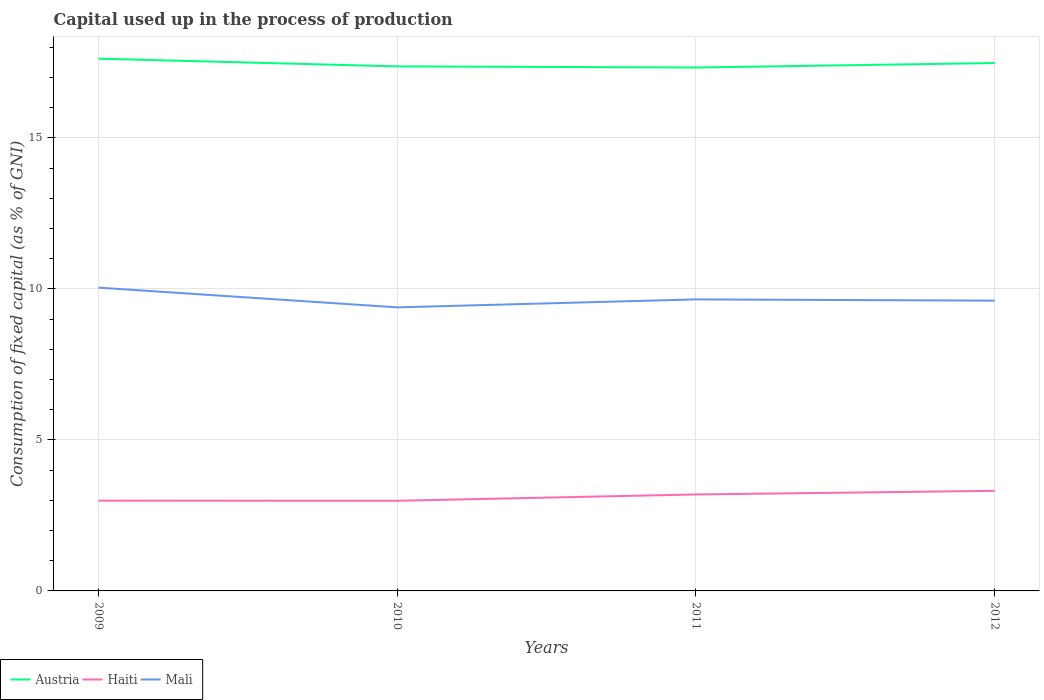Does the line corresponding to Austria intersect with the line corresponding to Mali?
Keep it short and to the point. No. Across all years, what is the maximum capital used up in the process of production in Austria?
Ensure brevity in your answer.  17.33. In which year was the capital used up in the process of production in Haiti maximum?
Keep it short and to the point. 2010. What is the total capital used up in the process of production in Haiti in the graph?
Provide a succinct answer. -0.2. What is the difference between the highest and the second highest capital used up in the process of production in Haiti?
Keep it short and to the point. 0.33. What is the difference between the highest and the lowest capital used up in the process of production in Haiti?
Provide a succinct answer. 2. How many lines are there?
Provide a short and direct response. 3. What is the difference between two consecutive major ticks on the Y-axis?
Your answer should be compact. 5. Does the graph contain any zero values?
Your answer should be compact. No. Where does the legend appear in the graph?
Offer a terse response. Bottom left. How are the legend labels stacked?
Provide a succinct answer. Horizontal. What is the title of the graph?
Your answer should be compact. Capital used up in the process of production. Does "Guam" appear as one of the legend labels in the graph?
Your response must be concise. No. What is the label or title of the Y-axis?
Give a very brief answer. Consumption of fixed capital (as % of GNI). What is the Consumption of fixed capital (as % of GNI) of Austria in 2009?
Provide a succinct answer. 17.62. What is the Consumption of fixed capital (as % of GNI) in Haiti in 2009?
Your response must be concise. 2.99. What is the Consumption of fixed capital (as % of GNI) of Mali in 2009?
Provide a short and direct response. 10.04. What is the Consumption of fixed capital (as % of GNI) of Austria in 2010?
Offer a very short reply. 17.37. What is the Consumption of fixed capital (as % of GNI) in Haiti in 2010?
Offer a very short reply. 2.98. What is the Consumption of fixed capital (as % of GNI) in Mali in 2010?
Offer a very short reply. 9.39. What is the Consumption of fixed capital (as % of GNI) of Austria in 2011?
Your response must be concise. 17.33. What is the Consumption of fixed capital (as % of GNI) of Haiti in 2011?
Your response must be concise. 3.19. What is the Consumption of fixed capital (as % of GNI) in Mali in 2011?
Your answer should be compact. 9.65. What is the Consumption of fixed capital (as % of GNI) of Austria in 2012?
Provide a short and direct response. 17.48. What is the Consumption of fixed capital (as % of GNI) of Haiti in 2012?
Offer a very short reply. 3.31. What is the Consumption of fixed capital (as % of GNI) in Mali in 2012?
Provide a short and direct response. 9.61. Across all years, what is the maximum Consumption of fixed capital (as % of GNI) in Austria?
Keep it short and to the point. 17.62. Across all years, what is the maximum Consumption of fixed capital (as % of GNI) in Haiti?
Your answer should be compact. 3.31. Across all years, what is the maximum Consumption of fixed capital (as % of GNI) of Mali?
Your answer should be very brief. 10.04. Across all years, what is the minimum Consumption of fixed capital (as % of GNI) in Austria?
Ensure brevity in your answer.  17.33. Across all years, what is the minimum Consumption of fixed capital (as % of GNI) in Haiti?
Your response must be concise. 2.98. Across all years, what is the minimum Consumption of fixed capital (as % of GNI) in Mali?
Offer a very short reply. 9.39. What is the total Consumption of fixed capital (as % of GNI) in Austria in the graph?
Offer a very short reply. 69.79. What is the total Consumption of fixed capital (as % of GNI) in Haiti in the graph?
Provide a succinct answer. 12.48. What is the total Consumption of fixed capital (as % of GNI) of Mali in the graph?
Provide a succinct answer. 38.69. What is the difference between the Consumption of fixed capital (as % of GNI) in Austria in 2009 and that in 2010?
Provide a succinct answer. 0.25. What is the difference between the Consumption of fixed capital (as % of GNI) in Haiti in 2009 and that in 2010?
Your answer should be compact. 0. What is the difference between the Consumption of fixed capital (as % of GNI) in Mali in 2009 and that in 2010?
Your response must be concise. 0.65. What is the difference between the Consumption of fixed capital (as % of GNI) in Austria in 2009 and that in 2011?
Provide a succinct answer. 0.29. What is the difference between the Consumption of fixed capital (as % of GNI) of Haiti in 2009 and that in 2011?
Provide a short and direct response. -0.2. What is the difference between the Consumption of fixed capital (as % of GNI) of Mali in 2009 and that in 2011?
Your response must be concise. 0.39. What is the difference between the Consumption of fixed capital (as % of GNI) in Austria in 2009 and that in 2012?
Your response must be concise. 0.14. What is the difference between the Consumption of fixed capital (as % of GNI) of Haiti in 2009 and that in 2012?
Provide a short and direct response. -0.32. What is the difference between the Consumption of fixed capital (as % of GNI) in Mali in 2009 and that in 2012?
Offer a very short reply. 0.43. What is the difference between the Consumption of fixed capital (as % of GNI) of Austria in 2010 and that in 2011?
Offer a terse response. 0.04. What is the difference between the Consumption of fixed capital (as % of GNI) of Haiti in 2010 and that in 2011?
Your answer should be compact. -0.21. What is the difference between the Consumption of fixed capital (as % of GNI) of Mali in 2010 and that in 2011?
Ensure brevity in your answer.  -0.26. What is the difference between the Consumption of fixed capital (as % of GNI) in Austria in 2010 and that in 2012?
Your response must be concise. -0.11. What is the difference between the Consumption of fixed capital (as % of GNI) in Haiti in 2010 and that in 2012?
Make the answer very short. -0.33. What is the difference between the Consumption of fixed capital (as % of GNI) of Mali in 2010 and that in 2012?
Offer a terse response. -0.22. What is the difference between the Consumption of fixed capital (as % of GNI) in Austria in 2011 and that in 2012?
Your answer should be very brief. -0.15. What is the difference between the Consumption of fixed capital (as % of GNI) in Haiti in 2011 and that in 2012?
Give a very brief answer. -0.12. What is the difference between the Consumption of fixed capital (as % of GNI) in Mali in 2011 and that in 2012?
Your response must be concise. 0.04. What is the difference between the Consumption of fixed capital (as % of GNI) of Austria in 2009 and the Consumption of fixed capital (as % of GNI) of Haiti in 2010?
Provide a succinct answer. 14.64. What is the difference between the Consumption of fixed capital (as % of GNI) of Austria in 2009 and the Consumption of fixed capital (as % of GNI) of Mali in 2010?
Keep it short and to the point. 8.23. What is the difference between the Consumption of fixed capital (as % of GNI) in Haiti in 2009 and the Consumption of fixed capital (as % of GNI) in Mali in 2010?
Your answer should be very brief. -6.4. What is the difference between the Consumption of fixed capital (as % of GNI) in Austria in 2009 and the Consumption of fixed capital (as % of GNI) in Haiti in 2011?
Your answer should be compact. 14.43. What is the difference between the Consumption of fixed capital (as % of GNI) in Austria in 2009 and the Consumption of fixed capital (as % of GNI) in Mali in 2011?
Provide a succinct answer. 7.97. What is the difference between the Consumption of fixed capital (as % of GNI) in Haiti in 2009 and the Consumption of fixed capital (as % of GNI) in Mali in 2011?
Your answer should be very brief. -6.66. What is the difference between the Consumption of fixed capital (as % of GNI) of Austria in 2009 and the Consumption of fixed capital (as % of GNI) of Haiti in 2012?
Provide a succinct answer. 14.31. What is the difference between the Consumption of fixed capital (as % of GNI) of Austria in 2009 and the Consumption of fixed capital (as % of GNI) of Mali in 2012?
Give a very brief answer. 8.01. What is the difference between the Consumption of fixed capital (as % of GNI) of Haiti in 2009 and the Consumption of fixed capital (as % of GNI) of Mali in 2012?
Offer a very short reply. -6.62. What is the difference between the Consumption of fixed capital (as % of GNI) of Austria in 2010 and the Consumption of fixed capital (as % of GNI) of Haiti in 2011?
Your answer should be compact. 14.17. What is the difference between the Consumption of fixed capital (as % of GNI) of Austria in 2010 and the Consumption of fixed capital (as % of GNI) of Mali in 2011?
Ensure brevity in your answer.  7.72. What is the difference between the Consumption of fixed capital (as % of GNI) of Haiti in 2010 and the Consumption of fixed capital (as % of GNI) of Mali in 2011?
Give a very brief answer. -6.67. What is the difference between the Consumption of fixed capital (as % of GNI) of Austria in 2010 and the Consumption of fixed capital (as % of GNI) of Haiti in 2012?
Provide a short and direct response. 14.05. What is the difference between the Consumption of fixed capital (as % of GNI) of Austria in 2010 and the Consumption of fixed capital (as % of GNI) of Mali in 2012?
Your answer should be compact. 7.76. What is the difference between the Consumption of fixed capital (as % of GNI) of Haiti in 2010 and the Consumption of fixed capital (as % of GNI) of Mali in 2012?
Make the answer very short. -6.63. What is the difference between the Consumption of fixed capital (as % of GNI) in Austria in 2011 and the Consumption of fixed capital (as % of GNI) in Haiti in 2012?
Your answer should be compact. 14.01. What is the difference between the Consumption of fixed capital (as % of GNI) of Austria in 2011 and the Consumption of fixed capital (as % of GNI) of Mali in 2012?
Your response must be concise. 7.72. What is the difference between the Consumption of fixed capital (as % of GNI) in Haiti in 2011 and the Consumption of fixed capital (as % of GNI) in Mali in 2012?
Make the answer very short. -6.42. What is the average Consumption of fixed capital (as % of GNI) of Austria per year?
Give a very brief answer. 17.45. What is the average Consumption of fixed capital (as % of GNI) of Haiti per year?
Make the answer very short. 3.12. What is the average Consumption of fixed capital (as % of GNI) in Mali per year?
Provide a short and direct response. 9.67. In the year 2009, what is the difference between the Consumption of fixed capital (as % of GNI) of Austria and Consumption of fixed capital (as % of GNI) of Haiti?
Offer a very short reply. 14.63. In the year 2009, what is the difference between the Consumption of fixed capital (as % of GNI) in Austria and Consumption of fixed capital (as % of GNI) in Mali?
Offer a terse response. 7.58. In the year 2009, what is the difference between the Consumption of fixed capital (as % of GNI) in Haiti and Consumption of fixed capital (as % of GNI) in Mali?
Give a very brief answer. -7.05. In the year 2010, what is the difference between the Consumption of fixed capital (as % of GNI) of Austria and Consumption of fixed capital (as % of GNI) of Haiti?
Give a very brief answer. 14.38. In the year 2010, what is the difference between the Consumption of fixed capital (as % of GNI) of Austria and Consumption of fixed capital (as % of GNI) of Mali?
Offer a terse response. 7.98. In the year 2010, what is the difference between the Consumption of fixed capital (as % of GNI) of Haiti and Consumption of fixed capital (as % of GNI) of Mali?
Your answer should be compact. -6.4. In the year 2011, what is the difference between the Consumption of fixed capital (as % of GNI) of Austria and Consumption of fixed capital (as % of GNI) of Haiti?
Provide a short and direct response. 14.13. In the year 2011, what is the difference between the Consumption of fixed capital (as % of GNI) in Austria and Consumption of fixed capital (as % of GNI) in Mali?
Provide a succinct answer. 7.68. In the year 2011, what is the difference between the Consumption of fixed capital (as % of GNI) of Haiti and Consumption of fixed capital (as % of GNI) of Mali?
Your answer should be very brief. -6.46. In the year 2012, what is the difference between the Consumption of fixed capital (as % of GNI) in Austria and Consumption of fixed capital (as % of GNI) in Haiti?
Your answer should be compact. 14.16. In the year 2012, what is the difference between the Consumption of fixed capital (as % of GNI) in Austria and Consumption of fixed capital (as % of GNI) in Mali?
Your response must be concise. 7.87. In the year 2012, what is the difference between the Consumption of fixed capital (as % of GNI) of Haiti and Consumption of fixed capital (as % of GNI) of Mali?
Offer a terse response. -6.3. What is the ratio of the Consumption of fixed capital (as % of GNI) of Austria in 2009 to that in 2010?
Make the answer very short. 1.01. What is the ratio of the Consumption of fixed capital (as % of GNI) in Mali in 2009 to that in 2010?
Make the answer very short. 1.07. What is the ratio of the Consumption of fixed capital (as % of GNI) of Austria in 2009 to that in 2011?
Provide a short and direct response. 1.02. What is the ratio of the Consumption of fixed capital (as % of GNI) in Haiti in 2009 to that in 2011?
Offer a very short reply. 0.94. What is the ratio of the Consumption of fixed capital (as % of GNI) in Mali in 2009 to that in 2011?
Offer a very short reply. 1.04. What is the ratio of the Consumption of fixed capital (as % of GNI) in Austria in 2009 to that in 2012?
Ensure brevity in your answer.  1.01. What is the ratio of the Consumption of fixed capital (as % of GNI) of Haiti in 2009 to that in 2012?
Make the answer very short. 0.9. What is the ratio of the Consumption of fixed capital (as % of GNI) in Mali in 2009 to that in 2012?
Ensure brevity in your answer.  1.04. What is the ratio of the Consumption of fixed capital (as % of GNI) of Haiti in 2010 to that in 2011?
Ensure brevity in your answer.  0.93. What is the ratio of the Consumption of fixed capital (as % of GNI) in Mali in 2010 to that in 2011?
Offer a terse response. 0.97. What is the ratio of the Consumption of fixed capital (as % of GNI) in Austria in 2010 to that in 2012?
Give a very brief answer. 0.99. What is the ratio of the Consumption of fixed capital (as % of GNI) of Haiti in 2010 to that in 2012?
Provide a short and direct response. 0.9. What is the ratio of the Consumption of fixed capital (as % of GNI) in Mali in 2010 to that in 2012?
Give a very brief answer. 0.98. What is the ratio of the Consumption of fixed capital (as % of GNI) in Haiti in 2011 to that in 2012?
Keep it short and to the point. 0.96. What is the difference between the highest and the second highest Consumption of fixed capital (as % of GNI) in Austria?
Offer a terse response. 0.14. What is the difference between the highest and the second highest Consumption of fixed capital (as % of GNI) in Haiti?
Your answer should be compact. 0.12. What is the difference between the highest and the second highest Consumption of fixed capital (as % of GNI) in Mali?
Provide a short and direct response. 0.39. What is the difference between the highest and the lowest Consumption of fixed capital (as % of GNI) in Austria?
Give a very brief answer. 0.29. What is the difference between the highest and the lowest Consumption of fixed capital (as % of GNI) in Haiti?
Provide a short and direct response. 0.33. What is the difference between the highest and the lowest Consumption of fixed capital (as % of GNI) in Mali?
Offer a very short reply. 0.65. 